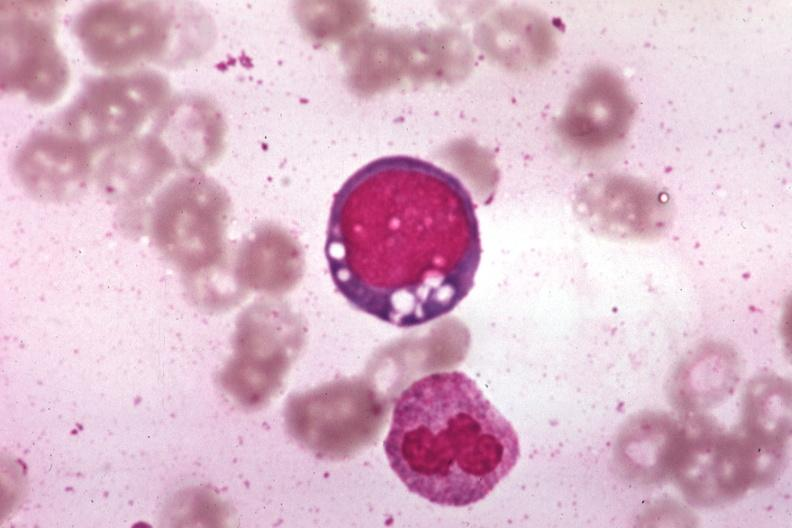s pus in test tube present?
Answer the question using a single word or phrase. No 